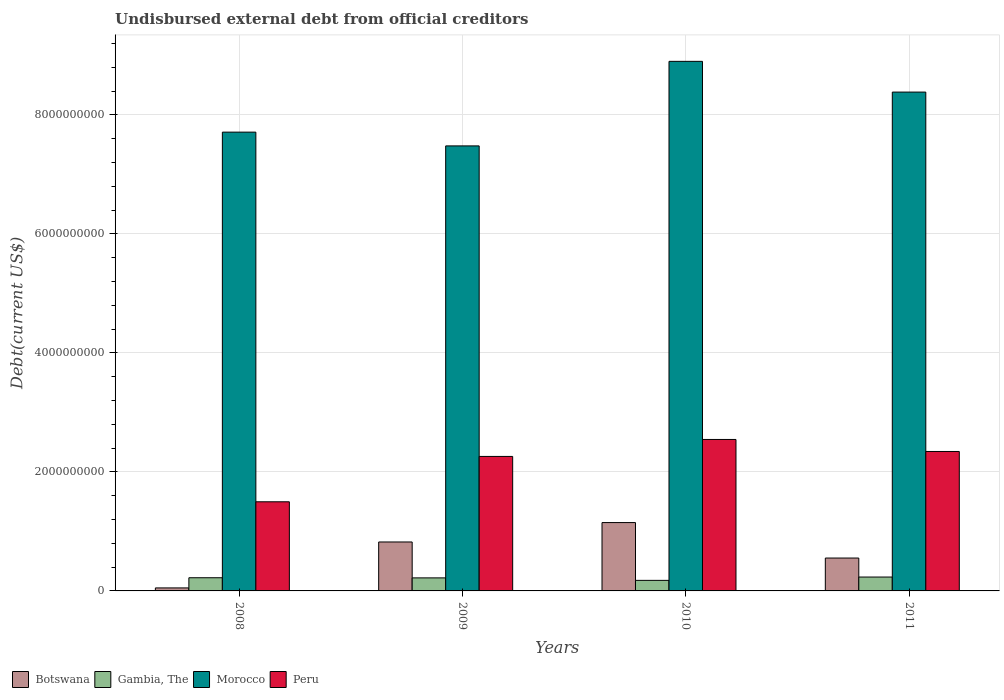How many different coloured bars are there?
Give a very brief answer. 4. Are the number of bars per tick equal to the number of legend labels?
Ensure brevity in your answer.  Yes. Are the number of bars on each tick of the X-axis equal?
Keep it short and to the point. Yes. How many bars are there on the 1st tick from the right?
Provide a succinct answer. 4. What is the label of the 1st group of bars from the left?
Your response must be concise. 2008. In how many cases, is the number of bars for a given year not equal to the number of legend labels?
Provide a short and direct response. 0. What is the total debt in Gambia, The in 2010?
Your answer should be very brief. 1.77e+08. Across all years, what is the maximum total debt in Peru?
Your answer should be compact. 2.55e+09. Across all years, what is the minimum total debt in Peru?
Your response must be concise. 1.50e+09. What is the total total debt in Gambia, The in the graph?
Offer a terse response. 8.51e+08. What is the difference between the total debt in Gambia, The in 2009 and that in 2011?
Ensure brevity in your answer.  -1.40e+07. What is the difference between the total debt in Botswana in 2008 and the total debt in Morocco in 2010?
Give a very brief answer. -8.85e+09. What is the average total debt in Morocco per year?
Your response must be concise. 8.12e+09. In the year 2008, what is the difference between the total debt in Botswana and total debt in Peru?
Your response must be concise. -1.45e+09. In how many years, is the total debt in Botswana greater than 1600000000 US$?
Keep it short and to the point. 0. What is the ratio of the total debt in Gambia, The in 2008 to that in 2009?
Keep it short and to the point. 1.01. What is the difference between the highest and the second highest total debt in Botswana?
Your answer should be very brief. 3.26e+08. What is the difference between the highest and the lowest total debt in Botswana?
Give a very brief answer. 1.10e+09. Is the sum of the total debt in Gambia, The in 2009 and 2011 greater than the maximum total debt in Botswana across all years?
Offer a terse response. No. What does the 4th bar from the left in 2009 represents?
Keep it short and to the point. Peru. What does the 2nd bar from the right in 2009 represents?
Your answer should be very brief. Morocco. Is it the case that in every year, the sum of the total debt in Peru and total debt in Gambia, The is greater than the total debt in Botswana?
Make the answer very short. Yes. How many years are there in the graph?
Ensure brevity in your answer.  4. Does the graph contain grids?
Make the answer very short. Yes. Where does the legend appear in the graph?
Make the answer very short. Bottom left. What is the title of the graph?
Your response must be concise. Undisbursed external debt from official creditors. Does "Chad" appear as one of the legend labels in the graph?
Your answer should be very brief. No. What is the label or title of the X-axis?
Ensure brevity in your answer.  Years. What is the label or title of the Y-axis?
Provide a short and direct response. Debt(current US$). What is the Debt(current US$) of Botswana in 2008?
Offer a very short reply. 5.04e+07. What is the Debt(current US$) of Gambia, The in 2008?
Provide a succinct answer. 2.21e+08. What is the Debt(current US$) of Morocco in 2008?
Your response must be concise. 7.71e+09. What is the Debt(current US$) of Peru in 2008?
Offer a very short reply. 1.50e+09. What is the Debt(current US$) of Botswana in 2009?
Provide a short and direct response. 8.23e+08. What is the Debt(current US$) in Gambia, The in 2009?
Your answer should be compact. 2.19e+08. What is the Debt(current US$) in Morocco in 2009?
Your answer should be very brief. 7.48e+09. What is the Debt(current US$) of Peru in 2009?
Provide a short and direct response. 2.26e+09. What is the Debt(current US$) in Botswana in 2010?
Ensure brevity in your answer.  1.15e+09. What is the Debt(current US$) of Gambia, The in 2010?
Offer a very short reply. 1.77e+08. What is the Debt(current US$) in Morocco in 2010?
Offer a terse response. 8.90e+09. What is the Debt(current US$) in Peru in 2010?
Give a very brief answer. 2.55e+09. What is the Debt(current US$) in Botswana in 2011?
Make the answer very short. 5.53e+08. What is the Debt(current US$) in Gambia, The in 2011?
Keep it short and to the point. 2.33e+08. What is the Debt(current US$) in Morocco in 2011?
Keep it short and to the point. 8.38e+09. What is the Debt(current US$) of Peru in 2011?
Make the answer very short. 2.34e+09. Across all years, what is the maximum Debt(current US$) of Botswana?
Your answer should be compact. 1.15e+09. Across all years, what is the maximum Debt(current US$) in Gambia, The?
Provide a short and direct response. 2.33e+08. Across all years, what is the maximum Debt(current US$) of Morocco?
Make the answer very short. 8.90e+09. Across all years, what is the maximum Debt(current US$) of Peru?
Your response must be concise. 2.55e+09. Across all years, what is the minimum Debt(current US$) of Botswana?
Give a very brief answer. 5.04e+07. Across all years, what is the minimum Debt(current US$) in Gambia, The?
Offer a very short reply. 1.77e+08. Across all years, what is the minimum Debt(current US$) in Morocco?
Your response must be concise. 7.48e+09. Across all years, what is the minimum Debt(current US$) in Peru?
Make the answer very short. 1.50e+09. What is the total Debt(current US$) of Botswana in the graph?
Give a very brief answer. 2.57e+09. What is the total Debt(current US$) of Gambia, The in the graph?
Provide a short and direct response. 8.51e+08. What is the total Debt(current US$) of Morocco in the graph?
Your answer should be compact. 3.25e+1. What is the total Debt(current US$) in Peru in the graph?
Keep it short and to the point. 8.65e+09. What is the difference between the Debt(current US$) in Botswana in 2008 and that in 2009?
Your answer should be compact. -7.72e+08. What is the difference between the Debt(current US$) of Gambia, The in 2008 and that in 2009?
Make the answer very short. 2.27e+06. What is the difference between the Debt(current US$) in Morocco in 2008 and that in 2009?
Give a very brief answer. 2.31e+08. What is the difference between the Debt(current US$) of Peru in 2008 and that in 2009?
Your answer should be very brief. -7.62e+08. What is the difference between the Debt(current US$) of Botswana in 2008 and that in 2010?
Your response must be concise. -1.10e+09. What is the difference between the Debt(current US$) of Gambia, The in 2008 and that in 2010?
Provide a succinct answer. 4.42e+07. What is the difference between the Debt(current US$) in Morocco in 2008 and that in 2010?
Ensure brevity in your answer.  -1.19e+09. What is the difference between the Debt(current US$) of Peru in 2008 and that in 2010?
Ensure brevity in your answer.  -1.05e+09. What is the difference between the Debt(current US$) of Botswana in 2008 and that in 2011?
Provide a succinct answer. -5.02e+08. What is the difference between the Debt(current US$) of Gambia, The in 2008 and that in 2011?
Give a very brief answer. -1.18e+07. What is the difference between the Debt(current US$) of Morocco in 2008 and that in 2011?
Keep it short and to the point. -6.73e+08. What is the difference between the Debt(current US$) in Peru in 2008 and that in 2011?
Provide a short and direct response. -8.45e+08. What is the difference between the Debt(current US$) of Botswana in 2009 and that in 2010?
Your answer should be very brief. -3.26e+08. What is the difference between the Debt(current US$) of Gambia, The in 2009 and that in 2010?
Provide a short and direct response. 4.19e+07. What is the difference between the Debt(current US$) of Morocco in 2009 and that in 2010?
Your response must be concise. -1.42e+09. What is the difference between the Debt(current US$) in Peru in 2009 and that in 2010?
Offer a very short reply. -2.85e+08. What is the difference between the Debt(current US$) of Botswana in 2009 and that in 2011?
Your answer should be very brief. 2.70e+08. What is the difference between the Debt(current US$) in Gambia, The in 2009 and that in 2011?
Provide a short and direct response. -1.40e+07. What is the difference between the Debt(current US$) of Morocco in 2009 and that in 2011?
Your answer should be compact. -9.05e+08. What is the difference between the Debt(current US$) of Peru in 2009 and that in 2011?
Offer a very short reply. -8.31e+07. What is the difference between the Debt(current US$) of Botswana in 2010 and that in 2011?
Your response must be concise. 5.96e+08. What is the difference between the Debt(current US$) in Gambia, The in 2010 and that in 2011?
Your response must be concise. -5.60e+07. What is the difference between the Debt(current US$) in Morocco in 2010 and that in 2011?
Keep it short and to the point. 5.16e+08. What is the difference between the Debt(current US$) in Peru in 2010 and that in 2011?
Offer a very short reply. 2.02e+08. What is the difference between the Debt(current US$) in Botswana in 2008 and the Debt(current US$) in Gambia, The in 2009?
Your response must be concise. -1.69e+08. What is the difference between the Debt(current US$) of Botswana in 2008 and the Debt(current US$) of Morocco in 2009?
Give a very brief answer. -7.43e+09. What is the difference between the Debt(current US$) in Botswana in 2008 and the Debt(current US$) in Peru in 2009?
Offer a terse response. -2.21e+09. What is the difference between the Debt(current US$) of Gambia, The in 2008 and the Debt(current US$) of Morocco in 2009?
Your answer should be compact. -7.26e+09. What is the difference between the Debt(current US$) of Gambia, The in 2008 and the Debt(current US$) of Peru in 2009?
Your answer should be very brief. -2.04e+09. What is the difference between the Debt(current US$) in Morocco in 2008 and the Debt(current US$) in Peru in 2009?
Your answer should be compact. 5.45e+09. What is the difference between the Debt(current US$) in Botswana in 2008 and the Debt(current US$) in Gambia, The in 2010?
Give a very brief answer. -1.27e+08. What is the difference between the Debt(current US$) in Botswana in 2008 and the Debt(current US$) in Morocco in 2010?
Your answer should be compact. -8.85e+09. What is the difference between the Debt(current US$) in Botswana in 2008 and the Debt(current US$) in Peru in 2010?
Your answer should be very brief. -2.49e+09. What is the difference between the Debt(current US$) of Gambia, The in 2008 and the Debt(current US$) of Morocco in 2010?
Your answer should be very brief. -8.68e+09. What is the difference between the Debt(current US$) of Gambia, The in 2008 and the Debt(current US$) of Peru in 2010?
Offer a terse response. -2.32e+09. What is the difference between the Debt(current US$) of Morocco in 2008 and the Debt(current US$) of Peru in 2010?
Give a very brief answer. 5.16e+09. What is the difference between the Debt(current US$) of Botswana in 2008 and the Debt(current US$) of Gambia, The in 2011?
Keep it short and to the point. -1.83e+08. What is the difference between the Debt(current US$) of Botswana in 2008 and the Debt(current US$) of Morocco in 2011?
Make the answer very short. -8.33e+09. What is the difference between the Debt(current US$) in Botswana in 2008 and the Debt(current US$) in Peru in 2011?
Your response must be concise. -2.29e+09. What is the difference between the Debt(current US$) of Gambia, The in 2008 and the Debt(current US$) of Morocco in 2011?
Offer a very short reply. -8.16e+09. What is the difference between the Debt(current US$) in Gambia, The in 2008 and the Debt(current US$) in Peru in 2011?
Ensure brevity in your answer.  -2.12e+09. What is the difference between the Debt(current US$) in Morocco in 2008 and the Debt(current US$) in Peru in 2011?
Your answer should be compact. 5.37e+09. What is the difference between the Debt(current US$) of Botswana in 2009 and the Debt(current US$) of Gambia, The in 2010?
Ensure brevity in your answer.  6.45e+08. What is the difference between the Debt(current US$) in Botswana in 2009 and the Debt(current US$) in Morocco in 2010?
Your answer should be compact. -8.08e+09. What is the difference between the Debt(current US$) of Botswana in 2009 and the Debt(current US$) of Peru in 2010?
Keep it short and to the point. -1.72e+09. What is the difference between the Debt(current US$) in Gambia, The in 2009 and the Debt(current US$) in Morocco in 2010?
Your answer should be very brief. -8.68e+09. What is the difference between the Debt(current US$) in Gambia, The in 2009 and the Debt(current US$) in Peru in 2010?
Your response must be concise. -2.33e+09. What is the difference between the Debt(current US$) in Morocco in 2009 and the Debt(current US$) in Peru in 2010?
Your answer should be very brief. 4.93e+09. What is the difference between the Debt(current US$) in Botswana in 2009 and the Debt(current US$) in Gambia, The in 2011?
Offer a very short reply. 5.89e+08. What is the difference between the Debt(current US$) of Botswana in 2009 and the Debt(current US$) of Morocco in 2011?
Offer a very short reply. -7.56e+09. What is the difference between the Debt(current US$) of Botswana in 2009 and the Debt(current US$) of Peru in 2011?
Provide a succinct answer. -1.52e+09. What is the difference between the Debt(current US$) of Gambia, The in 2009 and the Debt(current US$) of Morocco in 2011?
Your response must be concise. -8.16e+09. What is the difference between the Debt(current US$) of Gambia, The in 2009 and the Debt(current US$) of Peru in 2011?
Your answer should be compact. -2.12e+09. What is the difference between the Debt(current US$) of Morocco in 2009 and the Debt(current US$) of Peru in 2011?
Your answer should be compact. 5.14e+09. What is the difference between the Debt(current US$) of Botswana in 2010 and the Debt(current US$) of Gambia, The in 2011?
Give a very brief answer. 9.16e+08. What is the difference between the Debt(current US$) in Botswana in 2010 and the Debt(current US$) in Morocco in 2011?
Provide a short and direct response. -7.23e+09. What is the difference between the Debt(current US$) in Botswana in 2010 and the Debt(current US$) in Peru in 2011?
Your answer should be compact. -1.19e+09. What is the difference between the Debt(current US$) of Gambia, The in 2010 and the Debt(current US$) of Morocco in 2011?
Your response must be concise. -8.21e+09. What is the difference between the Debt(current US$) of Gambia, The in 2010 and the Debt(current US$) of Peru in 2011?
Make the answer very short. -2.17e+09. What is the difference between the Debt(current US$) in Morocco in 2010 and the Debt(current US$) in Peru in 2011?
Your answer should be compact. 6.56e+09. What is the average Debt(current US$) of Botswana per year?
Provide a short and direct response. 6.44e+08. What is the average Debt(current US$) in Gambia, The per year?
Give a very brief answer. 2.13e+08. What is the average Debt(current US$) of Morocco per year?
Offer a terse response. 8.12e+09. What is the average Debt(current US$) in Peru per year?
Provide a short and direct response. 2.16e+09. In the year 2008, what is the difference between the Debt(current US$) of Botswana and Debt(current US$) of Gambia, The?
Keep it short and to the point. -1.71e+08. In the year 2008, what is the difference between the Debt(current US$) of Botswana and Debt(current US$) of Morocco?
Ensure brevity in your answer.  -7.66e+09. In the year 2008, what is the difference between the Debt(current US$) of Botswana and Debt(current US$) of Peru?
Give a very brief answer. -1.45e+09. In the year 2008, what is the difference between the Debt(current US$) of Gambia, The and Debt(current US$) of Morocco?
Provide a succinct answer. -7.49e+09. In the year 2008, what is the difference between the Debt(current US$) of Gambia, The and Debt(current US$) of Peru?
Make the answer very short. -1.28e+09. In the year 2008, what is the difference between the Debt(current US$) in Morocco and Debt(current US$) in Peru?
Give a very brief answer. 6.21e+09. In the year 2009, what is the difference between the Debt(current US$) in Botswana and Debt(current US$) in Gambia, The?
Ensure brevity in your answer.  6.03e+08. In the year 2009, what is the difference between the Debt(current US$) of Botswana and Debt(current US$) of Morocco?
Offer a terse response. -6.66e+09. In the year 2009, what is the difference between the Debt(current US$) of Botswana and Debt(current US$) of Peru?
Provide a short and direct response. -1.44e+09. In the year 2009, what is the difference between the Debt(current US$) of Gambia, The and Debt(current US$) of Morocco?
Make the answer very short. -7.26e+09. In the year 2009, what is the difference between the Debt(current US$) of Gambia, The and Debt(current US$) of Peru?
Ensure brevity in your answer.  -2.04e+09. In the year 2009, what is the difference between the Debt(current US$) in Morocco and Debt(current US$) in Peru?
Provide a short and direct response. 5.22e+09. In the year 2010, what is the difference between the Debt(current US$) of Botswana and Debt(current US$) of Gambia, The?
Your response must be concise. 9.71e+08. In the year 2010, what is the difference between the Debt(current US$) of Botswana and Debt(current US$) of Morocco?
Ensure brevity in your answer.  -7.75e+09. In the year 2010, what is the difference between the Debt(current US$) in Botswana and Debt(current US$) in Peru?
Provide a succinct answer. -1.40e+09. In the year 2010, what is the difference between the Debt(current US$) in Gambia, The and Debt(current US$) in Morocco?
Give a very brief answer. -8.72e+09. In the year 2010, what is the difference between the Debt(current US$) in Gambia, The and Debt(current US$) in Peru?
Provide a succinct answer. -2.37e+09. In the year 2010, what is the difference between the Debt(current US$) in Morocco and Debt(current US$) in Peru?
Give a very brief answer. 6.35e+09. In the year 2011, what is the difference between the Debt(current US$) in Botswana and Debt(current US$) in Gambia, The?
Your response must be concise. 3.19e+08. In the year 2011, what is the difference between the Debt(current US$) of Botswana and Debt(current US$) of Morocco?
Provide a succinct answer. -7.83e+09. In the year 2011, what is the difference between the Debt(current US$) in Botswana and Debt(current US$) in Peru?
Provide a succinct answer. -1.79e+09. In the year 2011, what is the difference between the Debt(current US$) of Gambia, The and Debt(current US$) of Morocco?
Give a very brief answer. -8.15e+09. In the year 2011, what is the difference between the Debt(current US$) of Gambia, The and Debt(current US$) of Peru?
Ensure brevity in your answer.  -2.11e+09. In the year 2011, what is the difference between the Debt(current US$) of Morocco and Debt(current US$) of Peru?
Offer a very short reply. 6.04e+09. What is the ratio of the Debt(current US$) in Botswana in 2008 to that in 2009?
Your response must be concise. 0.06. What is the ratio of the Debt(current US$) in Gambia, The in 2008 to that in 2009?
Offer a very short reply. 1.01. What is the ratio of the Debt(current US$) of Morocco in 2008 to that in 2009?
Give a very brief answer. 1.03. What is the ratio of the Debt(current US$) in Peru in 2008 to that in 2009?
Offer a very short reply. 0.66. What is the ratio of the Debt(current US$) of Botswana in 2008 to that in 2010?
Your answer should be very brief. 0.04. What is the ratio of the Debt(current US$) of Gambia, The in 2008 to that in 2010?
Give a very brief answer. 1.25. What is the ratio of the Debt(current US$) in Morocco in 2008 to that in 2010?
Offer a terse response. 0.87. What is the ratio of the Debt(current US$) in Peru in 2008 to that in 2010?
Your answer should be compact. 0.59. What is the ratio of the Debt(current US$) of Botswana in 2008 to that in 2011?
Offer a very short reply. 0.09. What is the ratio of the Debt(current US$) in Gambia, The in 2008 to that in 2011?
Ensure brevity in your answer.  0.95. What is the ratio of the Debt(current US$) of Morocco in 2008 to that in 2011?
Your answer should be very brief. 0.92. What is the ratio of the Debt(current US$) in Peru in 2008 to that in 2011?
Keep it short and to the point. 0.64. What is the ratio of the Debt(current US$) in Botswana in 2009 to that in 2010?
Provide a succinct answer. 0.72. What is the ratio of the Debt(current US$) in Gambia, The in 2009 to that in 2010?
Offer a terse response. 1.24. What is the ratio of the Debt(current US$) in Morocco in 2009 to that in 2010?
Ensure brevity in your answer.  0.84. What is the ratio of the Debt(current US$) in Peru in 2009 to that in 2010?
Offer a terse response. 0.89. What is the ratio of the Debt(current US$) in Botswana in 2009 to that in 2011?
Offer a very short reply. 1.49. What is the ratio of the Debt(current US$) in Gambia, The in 2009 to that in 2011?
Make the answer very short. 0.94. What is the ratio of the Debt(current US$) in Morocco in 2009 to that in 2011?
Ensure brevity in your answer.  0.89. What is the ratio of the Debt(current US$) of Peru in 2009 to that in 2011?
Give a very brief answer. 0.96. What is the ratio of the Debt(current US$) of Botswana in 2010 to that in 2011?
Make the answer very short. 2.08. What is the ratio of the Debt(current US$) in Gambia, The in 2010 to that in 2011?
Give a very brief answer. 0.76. What is the ratio of the Debt(current US$) of Morocco in 2010 to that in 2011?
Offer a very short reply. 1.06. What is the ratio of the Debt(current US$) of Peru in 2010 to that in 2011?
Ensure brevity in your answer.  1.09. What is the difference between the highest and the second highest Debt(current US$) in Botswana?
Keep it short and to the point. 3.26e+08. What is the difference between the highest and the second highest Debt(current US$) in Gambia, The?
Your answer should be very brief. 1.18e+07. What is the difference between the highest and the second highest Debt(current US$) of Morocco?
Make the answer very short. 5.16e+08. What is the difference between the highest and the second highest Debt(current US$) of Peru?
Ensure brevity in your answer.  2.02e+08. What is the difference between the highest and the lowest Debt(current US$) in Botswana?
Give a very brief answer. 1.10e+09. What is the difference between the highest and the lowest Debt(current US$) in Gambia, The?
Keep it short and to the point. 5.60e+07. What is the difference between the highest and the lowest Debt(current US$) in Morocco?
Your response must be concise. 1.42e+09. What is the difference between the highest and the lowest Debt(current US$) of Peru?
Your answer should be very brief. 1.05e+09. 